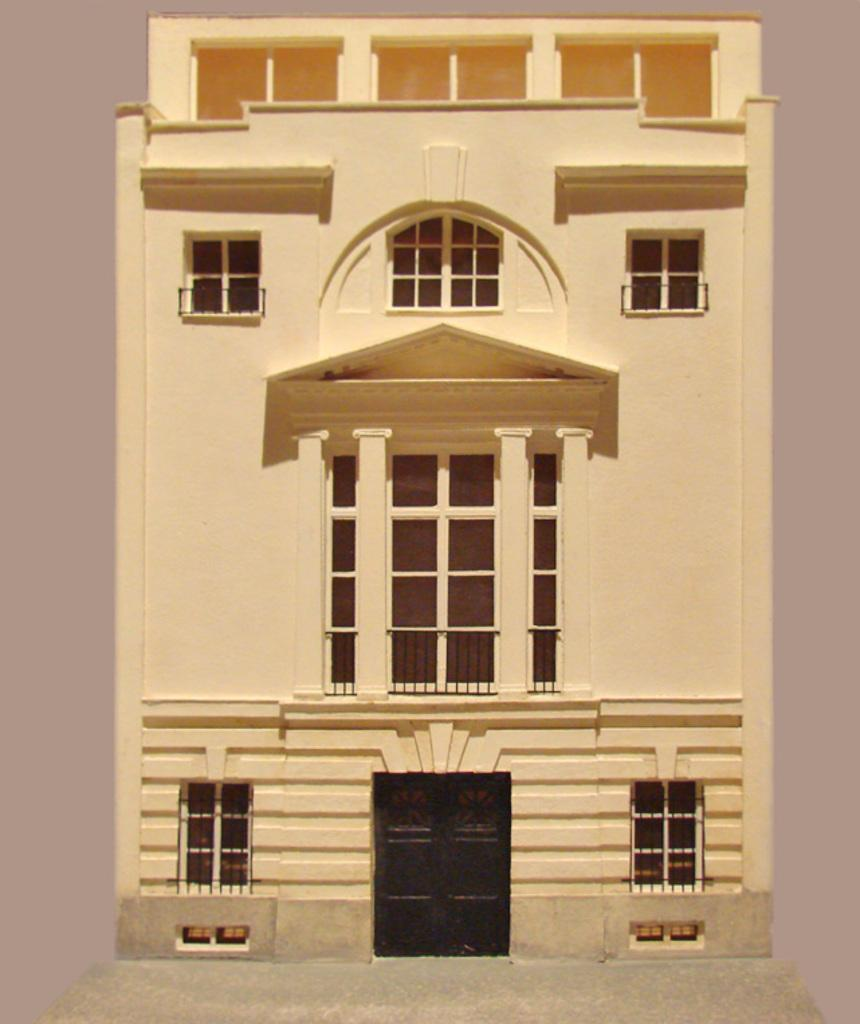What type of structure is visible in the image? There is a building in the image. What features can be seen on the building? The building has windows and doors. How many connections can be seen on the shelf in the image? There is no shelf present in the image, and therefore no connections can be seen. 